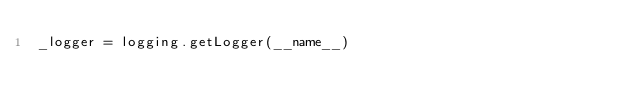Convert code to text. <code><loc_0><loc_0><loc_500><loc_500><_Python_>_logger = logging.getLogger(__name__)</code> 